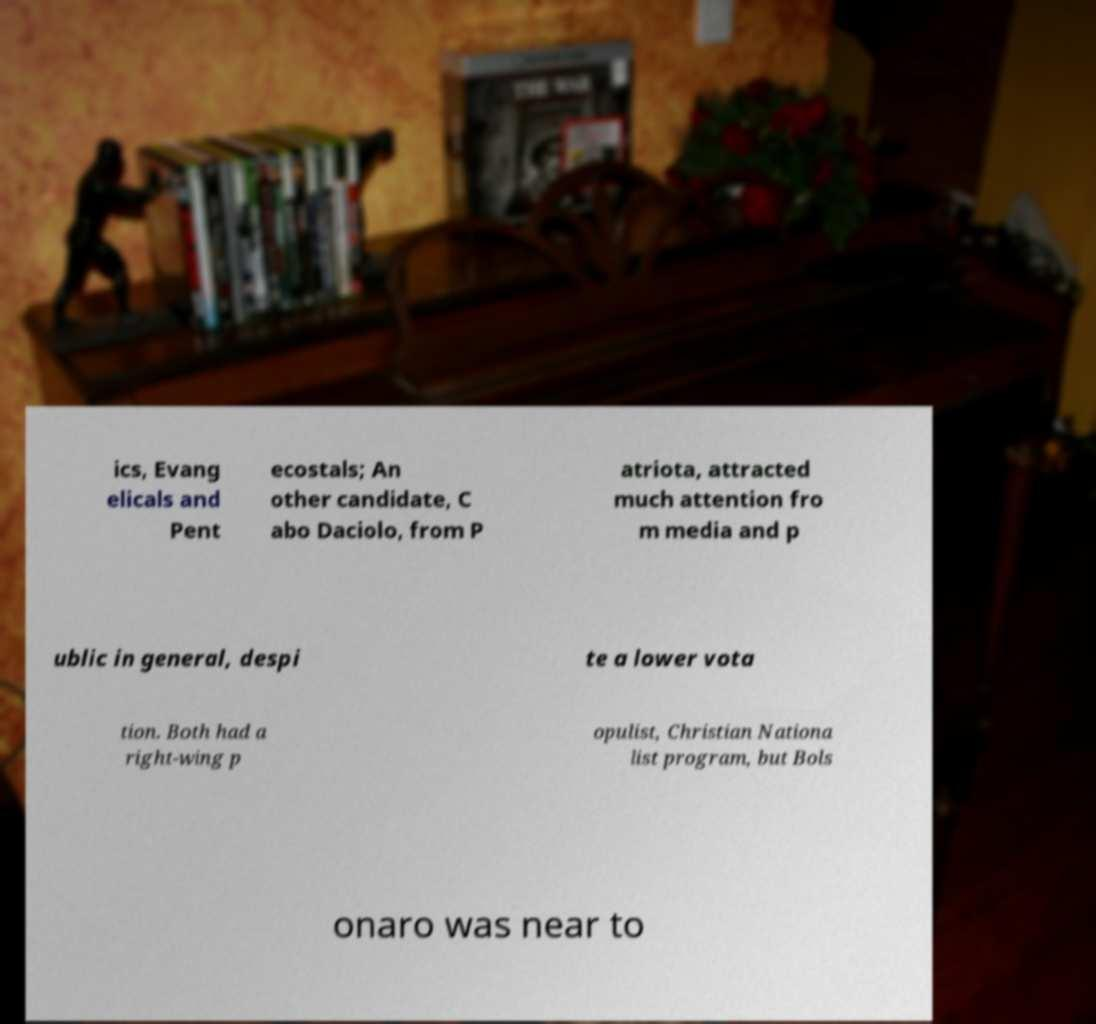Can you accurately transcribe the text from the provided image for me? ics, Evang elicals and Pent ecostals; An other candidate, C abo Daciolo, from P atriota, attracted much attention fro m media and p ublic in general, despi te a lower vota tion. Both had a right-wing p opulist, Christian Nationa list program, but Bols onaro was near to 